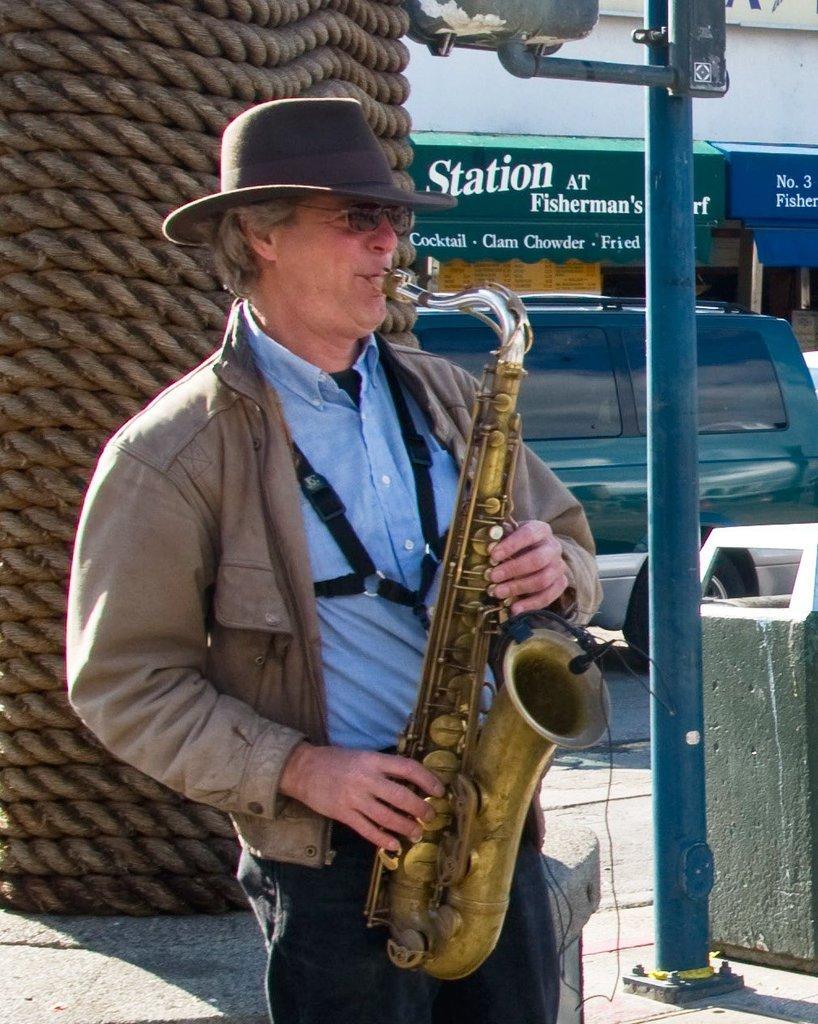How would you summarize this image in a sentence or two? In the picture we can see a man standing and playing a musical instrument holding it and he is wearing a hat and beside him we can see a pole and beside it, we can see a dustbin and some far away from it, we can see a car which is green in color and behind it we can see some shots to the building. 